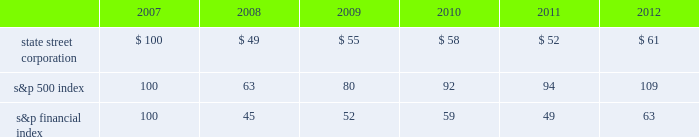Shareholder return performance presentation the graph presented below compares the cumulative total shareholder return on state street's common stock to the cumulative total return of the s&p 500 index and the s&p financial index over a five-year period .
The cumulative total shareholder return assumes the investment of $ 100 in state street common stock and in each index on december 31 , 2007 at the closing price on the last trading day of 2007 , and also assumes reinvestment of common stock dividends .
The s&p financial index is a publicly available measure of 80 of the standard & poor's 500 companies , representing 26 diversified financial services companies , 22 insurance companies , 17 real estate companies and 15 banking companies .
Comparison of five-year cumulative total shareholder return .

What is the cumulative total shareholder return on state street's common stock in 2012 as a percentage of the average shareholder return on common stock in the s&p 500? 
Computations: (61 / 109)
Answer: 0.55963. 